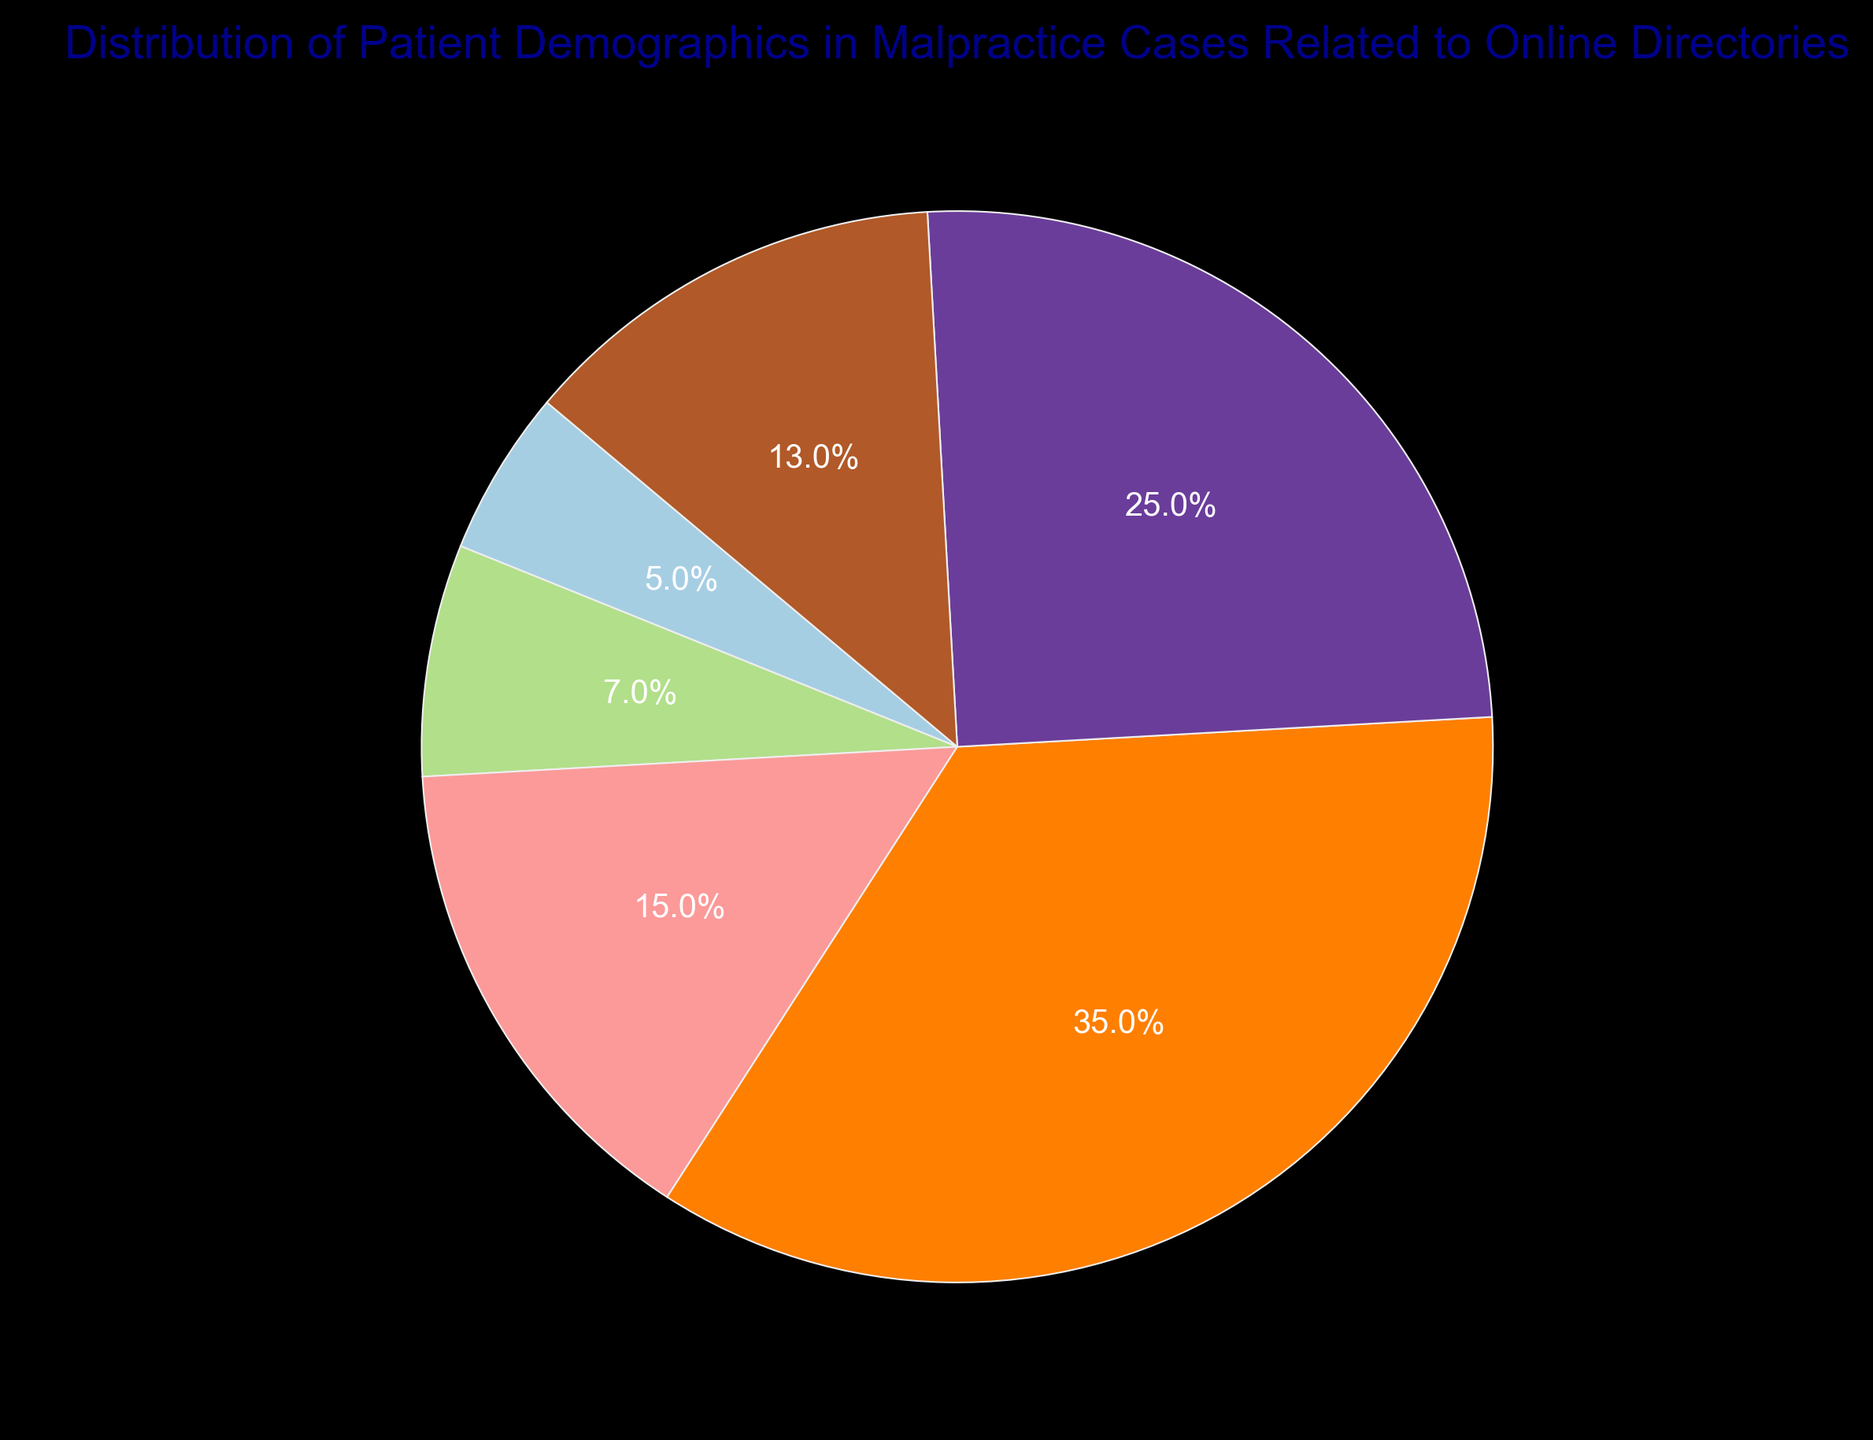Which demographic has the highest percentage of malpractice cases? The pie chart shows that the "Adults (26-45)" demographic has the largest section of the chart, indicating it has the highest percentage.
Answer: Adults (26-45) How much higher is the percentage of malpractice cases in the Adults (26-45) category compared to the Children (0-12) category? The percentage for Adults (26-45) is 35% and for Children (0-12) is 5%. Subtracting 5% from 35% gives 30%.
Answer: 30% What is the combined percentage of malpractice cases for middle-aged (46-65) and seniors (66+)? The percentage for middle-aged (46-65) is 25%, and for seniors (66+) it is 13%. Adding these together gives 38%.
Answer: 38% Which age group has the smallest percentage of malpractice cases? The pie chart shows that "Children (0-12)" has the smallest section, indicating it has the smallest percentage of cases.
Answer: Children (0-12) Compare the combined percentages of young adults (18-25) and adolescents (13-17) to that of adults (26-45). Which is greater? Young adults have 15% and adolescents have 7%, totaling 22%. Adults have 35%. Thus, the percentage for adults is greater.
Answer: Adults (26-45) What is the difference in malpractice case percentages between young adults (18-25) and seniors (66+)? Young adults (18-25) have 15%, and seniors (66+) have 13%. Subtracting 13% from 15% gives 2%.
Answer: 2% Identify the demographic group represented by a green wedge in the pie chart. Observing the color-coded pie chart, we can find the color green corresponds to the "Middle-aged (46-65)" demographic.
Answer: Middle-aged (46-65) How many demographics have a percentage of malpractice cases equal to or greater than 10%? The demographics with 10% or more are Young Adults (18-25) with 15%, Adults (26-45) with 35%, Middle-aged (46-65) with 25%, and Seniors (66+) with 13%. This gives a total of four demographics.
Answer: 4 If the percentages were converted to degrees of a circle, what would be the angle representing the adolescents (13-17) demographic? Adolescents (13-17) make up 7% of the pie chart. In a full circle of 360 degrees, 7% would be 0.07 * 360 degrees, which equals 25.2 degrees.
Answer: 25.2 degrees 